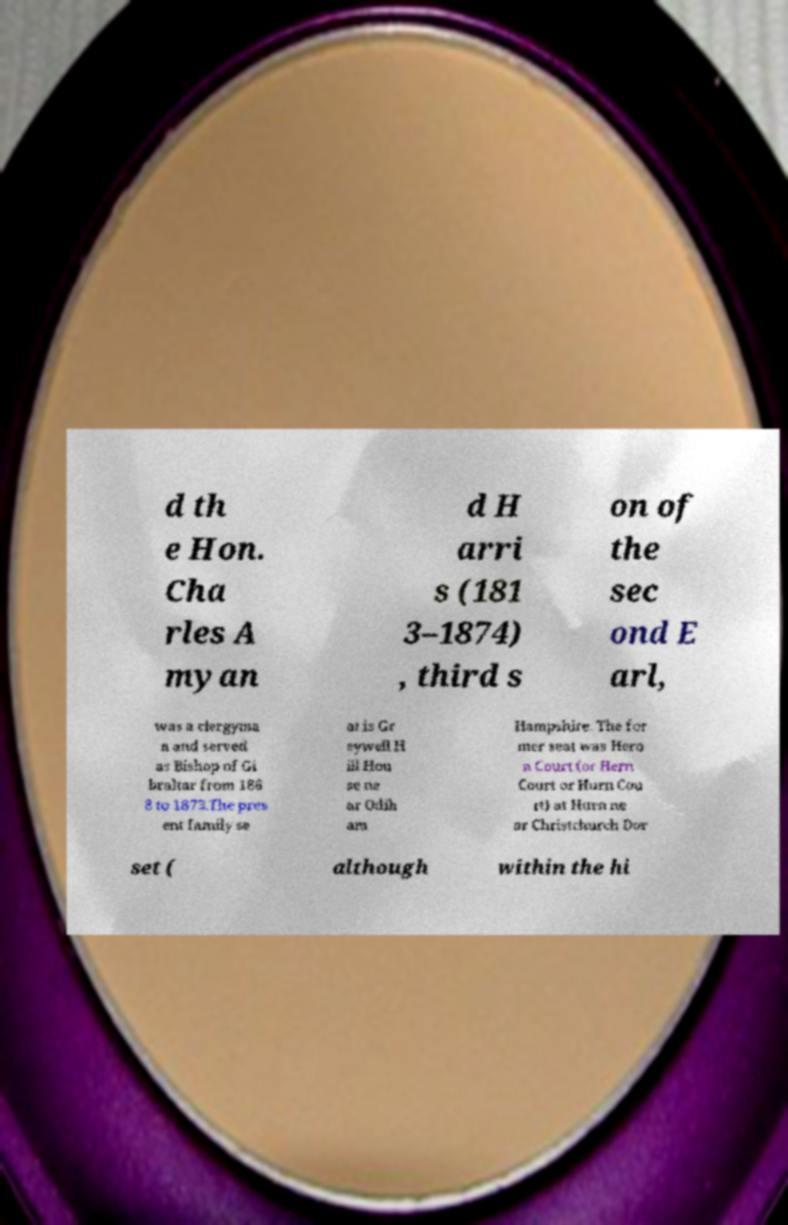There's text embedded in this image that I need extracted. Can you transcribe it verbatim? d th e Hon. Cha rles A myan d H arri s (181 3–1874) , third s on of the sec ond E arl, was a clergyma n and served as Bishop of Gi braltar from 186 8 to 1873.The pres ent family se at is Gr eywell H ill Hou se ne ar Odih am Hampshire. The for mer seat was Hero n Court (or Hern Court or Hurn Cou rt) at Hurn ne ar Christchurch Dor set ( although within the hi 